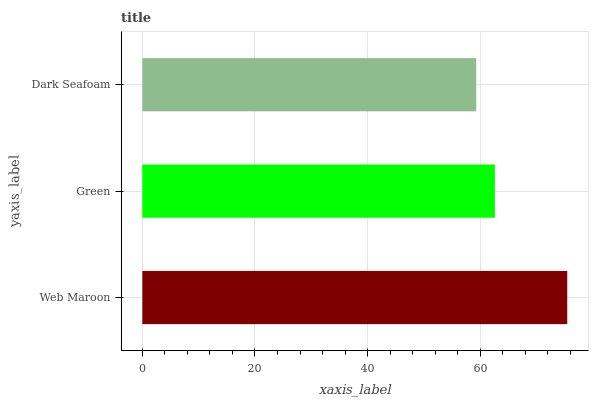Is Dark Seafoam the minimum?
Answer yes or no. Yes. Is Web Maroon the maximum?
Answer yes or no. Yes. Is Green the minimum?
Answer yes or no. No. Is Green the maximum?
Answer yes or no. No. Is Web Maroon greater than Green?
Answer yes or no. Yes. Is Green less than Web Maroon?
Answer yes or no. Yes. Is Green greater than Web Maroon?
Answer yes or no. No. Is Web Maroon less than Green?
Answer yes or no. No. Is Green the high median?
Answer yes or no. Yes. Is Green the low median?
Answer yes or no. Yes. Is Web Maroon the high median?
Answer yes or no. No. Is Dark Seafoam the low median?
Answer yes or no. No. 